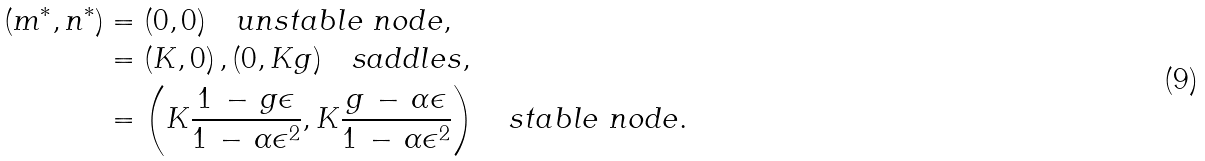<formula> <loc_0><loc_0><loc_500><loc_500>( m ^ { * } , n ^ { * } ) & = ( 0 , 0 ) \quad u n s t a b l e \ n o d e , \\ & = ( K , 0 ) \, , ( 0 , K g ) \quad s a d d l e s , \\ & = \left ( K \frac { 1 \, - \, g \epsilon } { 1 \, - \, \alpha \epsilon ^ { 2 } } , K \frac { g \, - \, \alpha \epsilon } { 1 \, - \, \alpha \epsilon ^ { 2 } } \right ) \quad s t a b l e \ n o d e .</formula> 